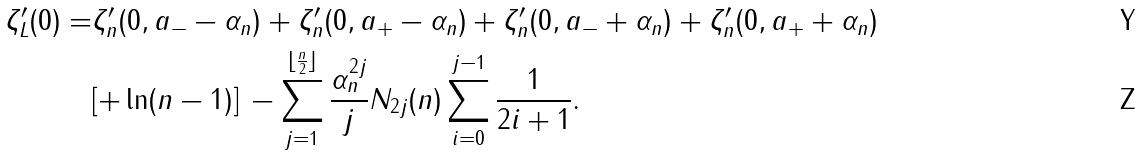Convert formula to latex. <formula><loc_0><loc_0><loc_500><loc_500>\zeta _ { L } ^ { \prime } ( 0 ) = & \zeta _ { n } ^ { \prime } ( 0 , a _ { - } - \alpha _ { n } ) + \zeta _ { n } ^ { \prime } ( 0 , a _ { + } - \alpha _ { n } ) + \zeta _ { n } ^ { \prime } ( 0 , a _ { - } + \alpha _ { n } ) + \zeta _ { n } ^ { \prime } ( 0 , a _ { + } + \alpha _ { n } ) \\ & [ + \ln ( n - 1 ) ] \, - \sum _ { j = 1 } ^ { \lfloor \frac { n } { 2 } \rfloor } \frac { \alpha _ { n } ^ { 2 j } } { j } N _ { 2 j } ( n ) \sum _ { i = 0 } ^ { j - 1 } \frac { 1 } { 2 i + 1 } .</formula> 